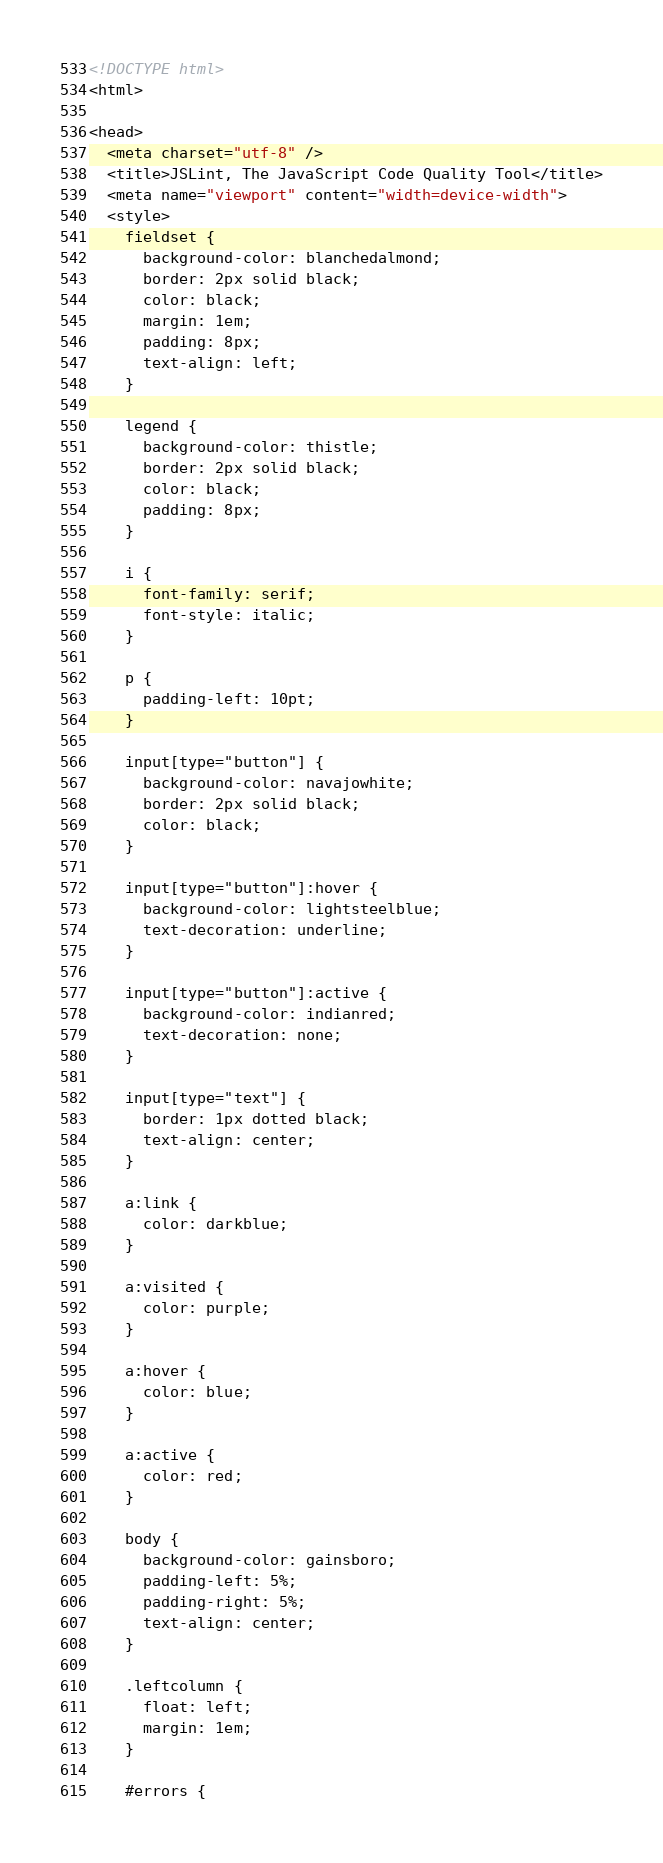Convert code to text. <code><loc_0><loc_0><loc_500><loc_500><_HTML_><!DOCTYPE html>
<html>

<head>
  <meta charset="utf-8" />
  <title>JSLint, The JavaScript Code Quality Tool</title>
  <meta name="viewport" content="width=device-width">
  <style>
    fieldset {
      background-color: blanchedalmond;
      border: 2px solid black;
      color: black;
      margin: 1em;
      padding: 8px;
      text-align: left;
    }

    legend {
      background-color: thistle;
      border: 2px solid black;
      color: black;
      padding: 8px;
    }

    i {
      font-family: serif;
      font-style: italic;
    }

    p {
      padding-left: 10pt;
    }

    input[type="button"] {
      background-color: navajowhite;
      border: 2px solid black;
      color: black;
    }

    input[type="button"]:hover {
      background-color: lightsteelblue;
      text-decoration: underline;
    }

    input[type="button"]:active {
      background-color: indianred;
      text-decoration: none;
    }

    input[type="text"] {
      border: 1px dotted black;
      text-align: center;
    }

    a:link {
      color: darkblue;
    }

    a:visited {
      color: purple;
    }

    a:hover {
      color: blue;
    }

    a:active {
      color: red;
    }

    body {
      background-color: gainsboro;
      padding-left: 5%;
      padding-right: 5%;
      text-align: center;
    }

    .leftcolumn {
      float: left;
      margin: 1em;
    }

    #errors {</code> 